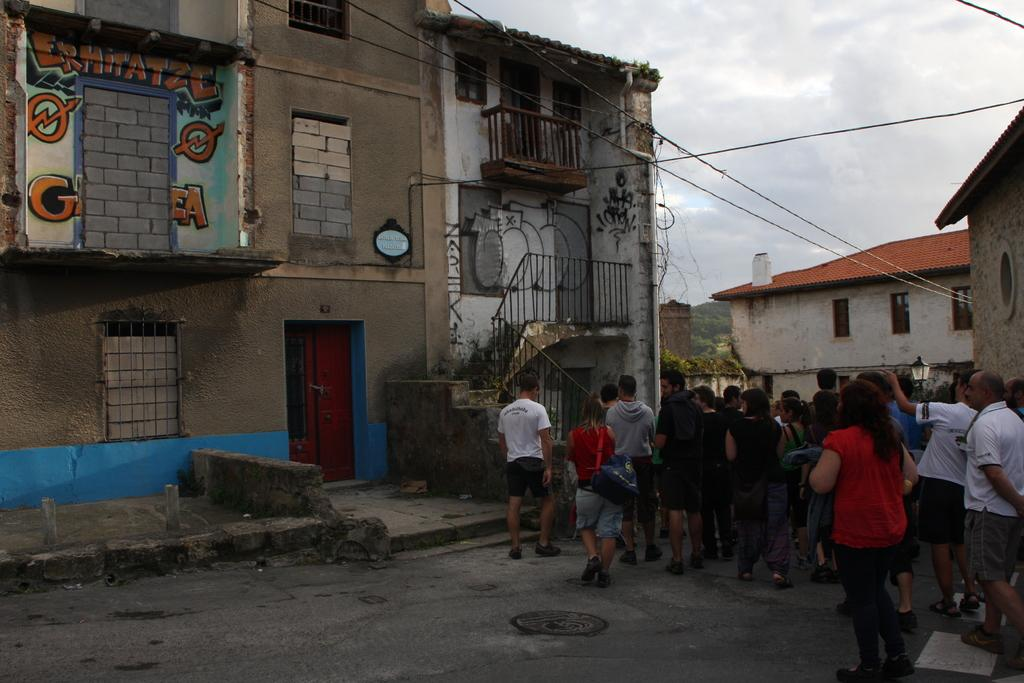What are the people in the image doing? The people in the image are walking on a road. What can be seen in the background of the image? There are houses and the sky visible in the background of the image. Can you see any islands in the image? There are no islands present in the image; it features people walking on a road with houses and the sky in the background. 